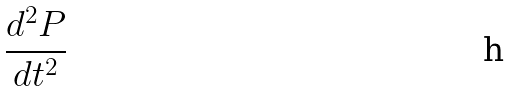Convert formula to latex. <formula><loc_0><loc_0><loc_500><loc_500>\frac { d ^ { 2 } P } { d t ^ { 2 } }</formula> 